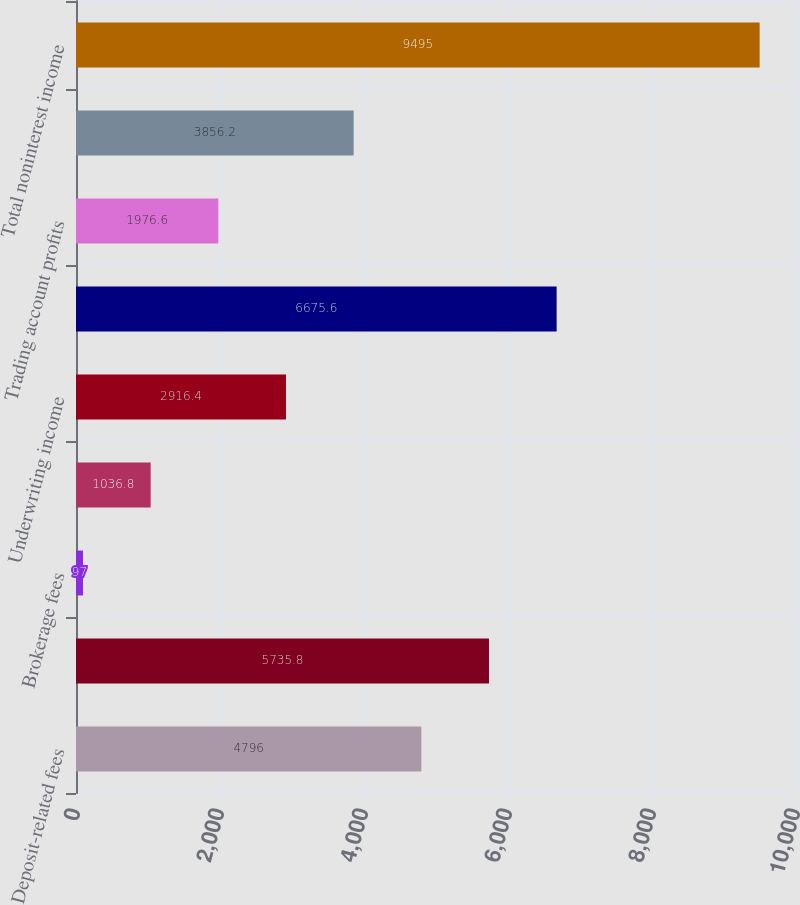<chart> <loc_0><loc_0><loc_500><loc_500><bar_chart><fcel>Deposit-related fees<fcel>Total service charges<fcel>Brokerage fees<fcel>Total investment and brokerage<fcel>Underwriting income<fcel>Total investment banking<fcel>Trading account profits<fcel>Other income<fcel>Total noninterest income<nl><fcel>4796<fcel>5735.8<fcel>97<fcel>1036.8<fcel>2916.4<fcel>6675.6<fcel>1976.6<fcel>3856.2<fcel>9495<nl></chart> 